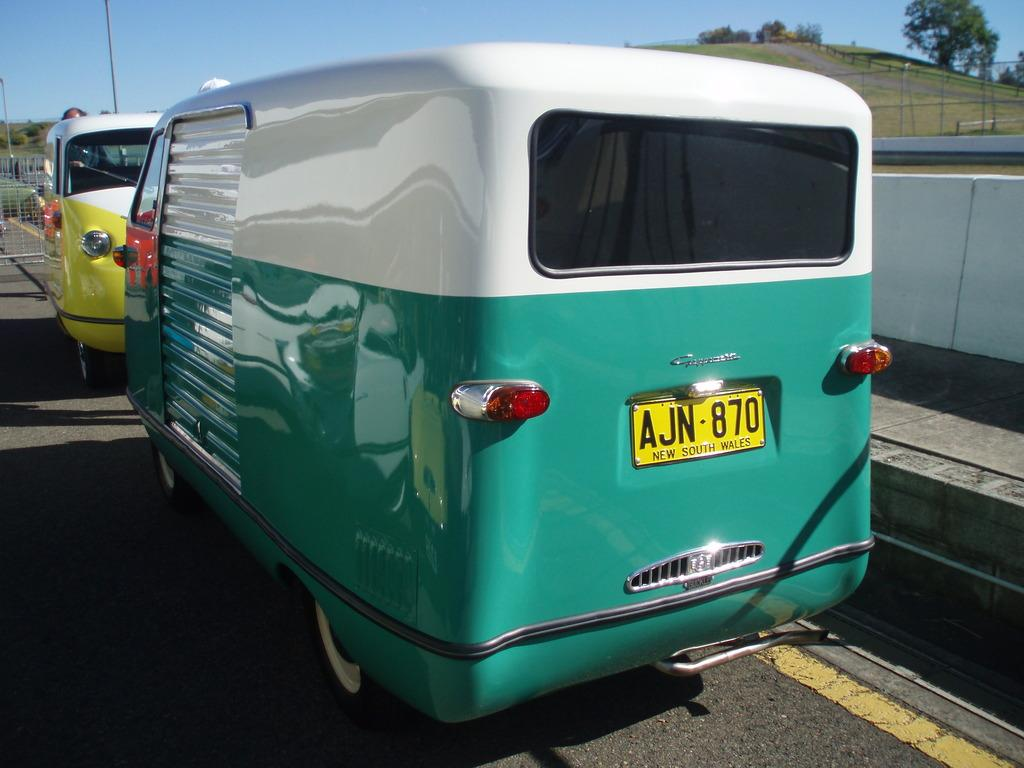<image>
Render a clear and concise summary of the photo. The cute green and white camper van is from New South Wales. 